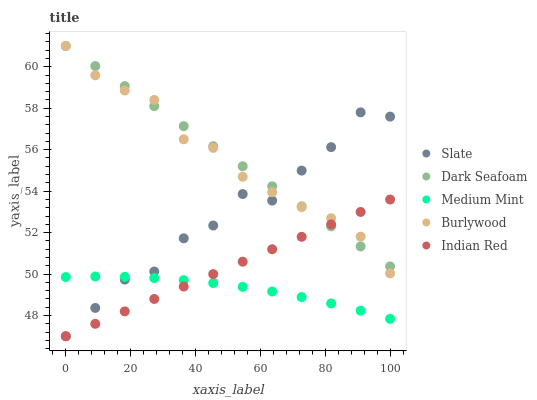Does Medium Mint have the minimum area under the curve?
Answer yes or no. Yes. Does Dark Seafoam have the maximum area under the curve?
Answer yes or no. Yes. Does Burlywood have the minimum area under the curve?
Answer yes or no. No. Does Burlywood have the maximum area under the curve?
Answer yes or no. No. Is Indian Red the smoothest?
Answer yes or no. Yes. Is Slate the roughest?
Answer yes or no. Yes. Is Burlywood the smoothest?
Answer yes or no. No. Is Burlywood the roughest?
Answer yes or no. No. Does Slate have the lowest value?
Answer yes or no. Yes. Does Burlywood have the lowest value?
Answer yes or no. No. Does Dark Seafoam have the highest value?
Answer yes or no. Yes. Does Slate have the highest value?
Answer yes or no. No. Is Medium Mint less than Burlywood?
Answer yes or no. Yes. Is Burlywood greater than Medium Mint?
Answer yes or no. Yes. Does Indian Red intersect Burlywood?
Answer yes or no. Yes. Is Indian Red less than Burlywood?
Answer yes or no. No. Is Indian Red greater than Burlywood?
Answer yes or no. No. Does Medium Mint intersect Burlywood?
Answer yes or no. No. 